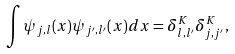<formula> <loc_0><loc_0><loc_500><loc_500>\int \psi _ { j , l } ( x ) \psi _ { j ^ { \prime } , l ^ { \prime } } ( x ) d x = \delta ^ { K } _ { l , l ^ { \prime } } \delta ^ { K } _ { j , j ^ { \prime } } ,</formula> 